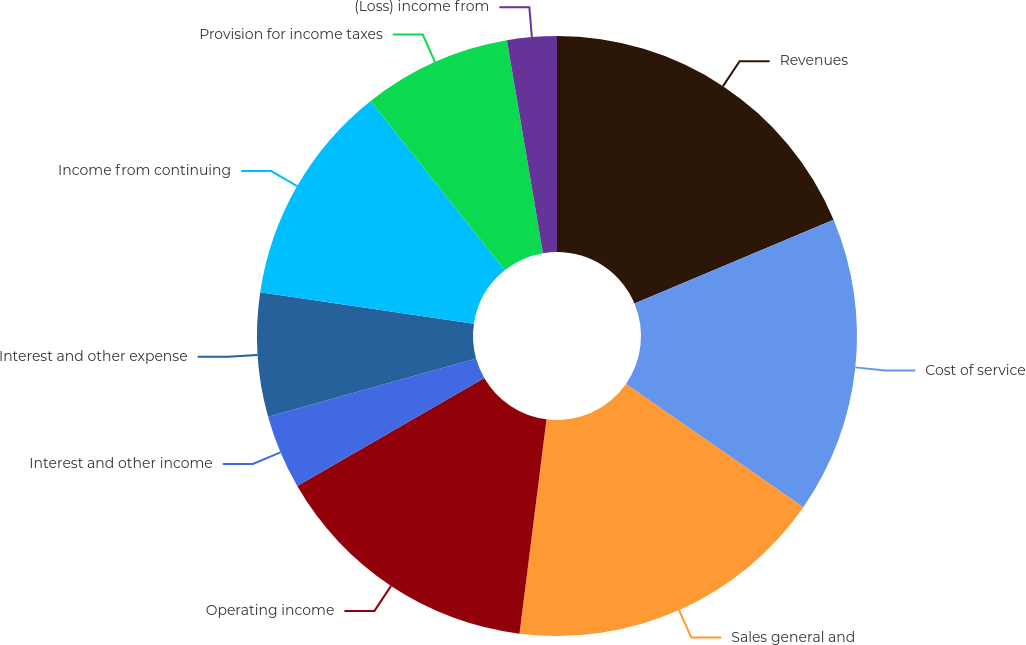Convert chart. <chart><loc_0><loc_0><loc_500><loc_500><pie_chart><fcel>Revenues<fcel>Cost of service<fcel>Sales general and<fcel>Operating income<fcel>Interest and other income<fcel>Interest and other expense<fcel>Income from continuing<fcel>Provision for income taxes<fcel>(Loss) income from<nl><fcel>18.67%<fcel>16.0%<fcel>17.33%<fcel>14.67%<fcel>4.0%<fcel>6.67%<fcel>12.0%<fcel>8.0%<fcel>2.67%<nl></chart> 